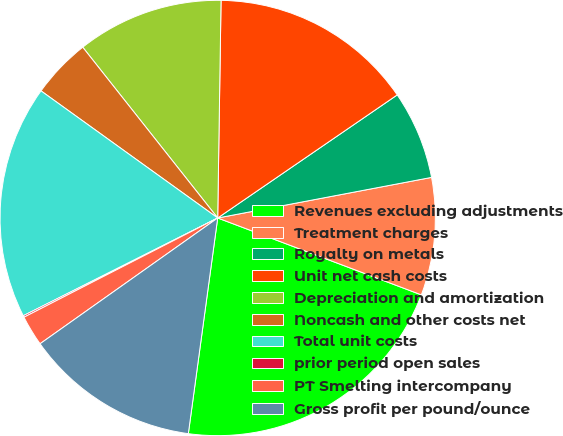<chart> <loc_0><loc_0><loc_500><loc_500><pie_chart><fcel>Revenues excluding adjustments<fcel>Treatment charges<fcel>Royalty on metals<fcel>Unit net cash costs<fcel>Depreciation and amortization<fcel>Noncash and other costs net<fcel>Total unit costs<fcel>prior period open sales<fcel>PT Smelting intercompany<fcel>Gross profit per pound/ounce<nl><fcel>21.41%<fcel>8.73%<fcel>6.58%<fcel>15.19%<fcel>10.89%<fcel>4.43%<fcel>17.34%<fcel>0.12%<fcel>2.27%<fcel>13.04%<nl></chart> 